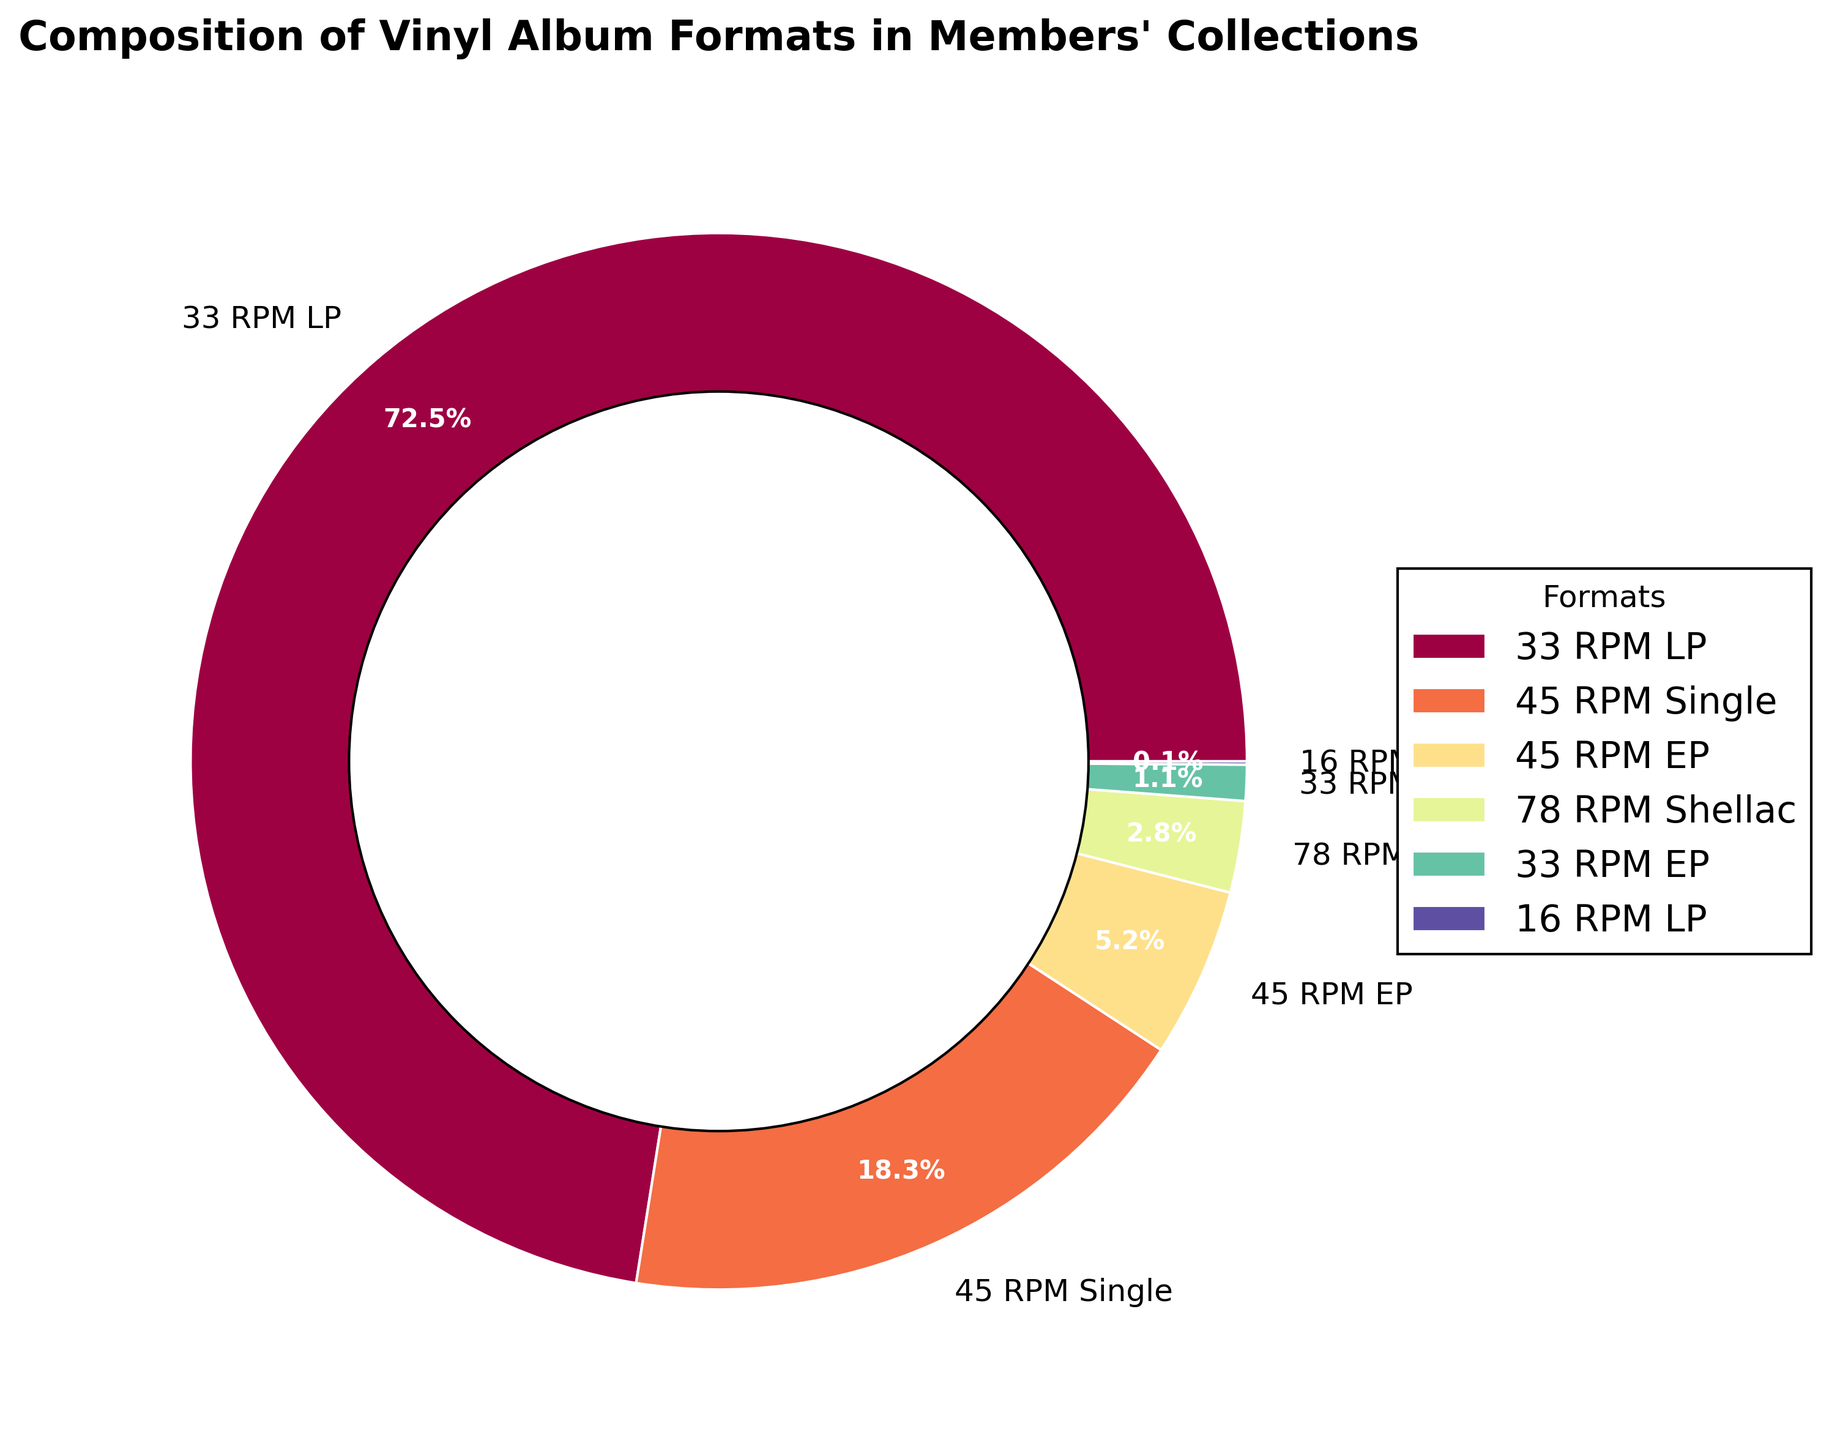What's the sum of the percentages of 33 RPM LP and 45 RPM Single? To find the sum, look at the percentages for 33 RPM LP and 45 RPM Single. The percentages are 72.5% and 18.3%, respectively. Add these two numbers together: 72.5 + 18.3 = 90.8%.
Answer: 90.8% Which format has the smallest percentage in members' collections? Look at all the segment labels and their corresponding percentages in the pie chart. The 16 RPM LP has the smallest percentage of 0.1%.
Answer: 16 RPM LP Are there more 45 RPM EPs or 78 RPM Shellacs? Compare the percentages for 45 RPM EP (5.2%) and 78 RPM Shellac (2.8%). Since 5.2% is greater than 2.8%, there are more 45 RPM EPs.
Answer: 45 RPM EPs What is the difference in percentage between 33 RPM LP and the total of all 45 RPM formats combined? First, sum the percentages of all 45 RPM formats: 45 RPM Single (18.3%) + 45 RPM EP (5.2%) = 23.5%. Then subtract this sum from the percentage of 33 RPM LP: 72.5% - 23.5% = 49%.
Answer: 49% What percentage do 33 RPM LP and 33 RPM EP formats together account for? To find the combined percentage, add the percentages of 33 RPM LP (72.5%) and 33 RPM EP (1.1%): 72.5 + 1.1 = 73.6%.
Answer: 73.6% Which format occupies the largest segment visually? Identify the largest segment in the pie chart by its size and label. The largest segment is for the 33 RPM LP format, which occupies 72.5% of the pie chart.
Answer: 33 RPM LP By how much does the 45 RPM Single percentage exceed the 78 RPM Shellac percentage? Subtract the percentage of 78 RPM Shellac (2.8%) from the percentage of 45 RPM Single (18.3%): 18.3 - 2.8 = 15.5%.
Answer: 15.5% What's the average percentage of all 45 RPM formats combined? First, sum the percentages of the 45 RPM Single and 45 RPM EP: 18.3% + 5.2% = 23.5%. There are 2 formats within 45 RPM, so divide this sum by 2: 23.5 / 2 = 11.75%.
Answer: 11.75% 